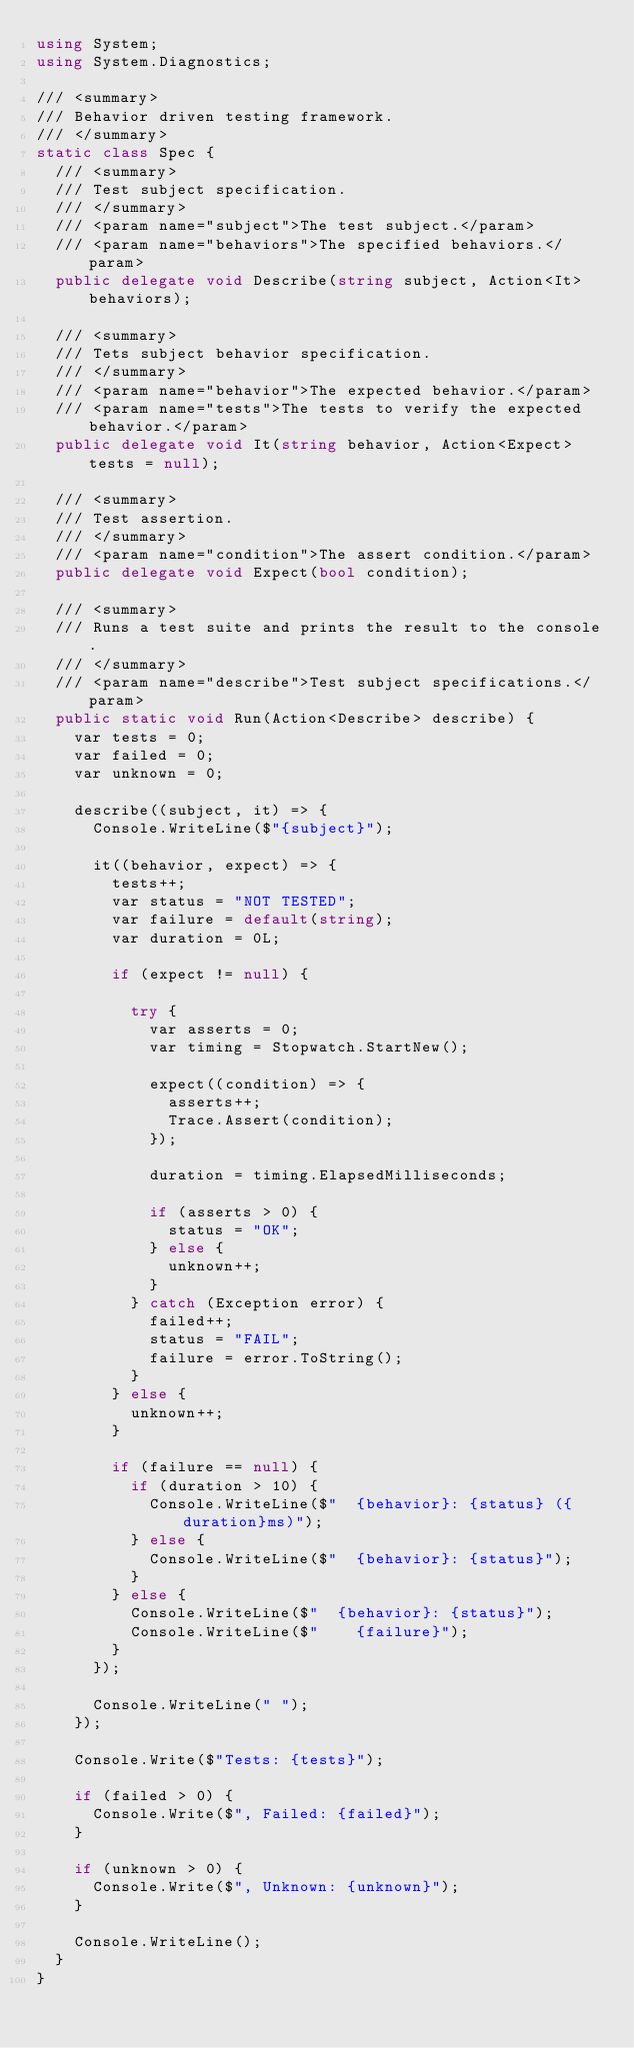Convert code to text. <code><loc_0><loc_0><loc_500><loc_500><_C#_>using System;
using System.Diagnostics;

/// <summary>
/// Behavior driven testing framework.
/// </summary>
static class Spec {
  /// <summary>
  /// Test subject specification.
  /// </summary>
  /// <param name="subject">The test subject.</param>
  /// <param name="behaviors">The specified behaviors.</param>
  public delegate void Describe(string subject, Action<It> behaviors);

  /// <summary>
  /// Tets subject behavior specification.
  /// </summary>
  /// <param name="behavior">The expected behavior.</param>
  /// <param name="tests">The tests to verify the expected behavior.</param>
  public delegate void It(string behavior, Action<Expect> tests = null);

  /// <summary>
  /// Test assertion.
  /// </summary>
  /// <param name="condition">The assert condition.</param>
  public delegate void Expect(bool condition);

  /// <summary>
  /// Runs a test suite and prints the result to the console.
  /// </summary>
  /// <param name="describe">Test subject specifications.</param>
  public static void Run(Action<Describe> describe) {
    var tests = 0;
    var failed = 0;
    var unknown = 0;

    describe((subject, it) => {
      Console.WriteLine($"{subject}");

      it((behavior, expect) => {
        tests++;
        var status = "NOT TESTED";
        var failure = default(string);
        var duration = 0L;

        if (expect != null) {

          try {
            var asserts = 0;
            var timing = Stopwatch.StartNew();

            expect((condition) => {
              asserts++;
              Trace.Assert(condition);
            });

            duration = timing.ElapsedMilliseconds;

            if (asserts > 0) {
              status = "OK";
            } else {
              unknown++;
            }
          } catch (Exception error) {
            failed++;
            status = "FAIL";
            failure = error.ToString();
          }
        } else {
          unknown++;
        }

        if (failure == null) {
          if (duration > 10) {
            Console.WriteLine($"  {behavior}: {status} ({duration}ms)");
          } else {
            Console.WriteLine($"  {behavior}: {status}");
          }
        } else {
          Console.WriteLine($"  {behavior}: {status}");
          Console.WriteLine($"    {failure}");
        }
      });

      Console.WriteLine(" ");
    });

    Console.Write($"Tests: {tests}");

    if (failed > 0) {
      Console.Write($", Failed: {failed}");
    }

    if (unknown > 0) {
      Console.Write($", Unknown: {unknown}");
    }

    Console.WriteLine();
  }
}
</code> 